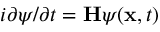Convert formula to latex. <formula><loc_0><loc_0><loc_500><loc_500>i \partial \psi / \partial t = H \psi ( x , t )</formula> 